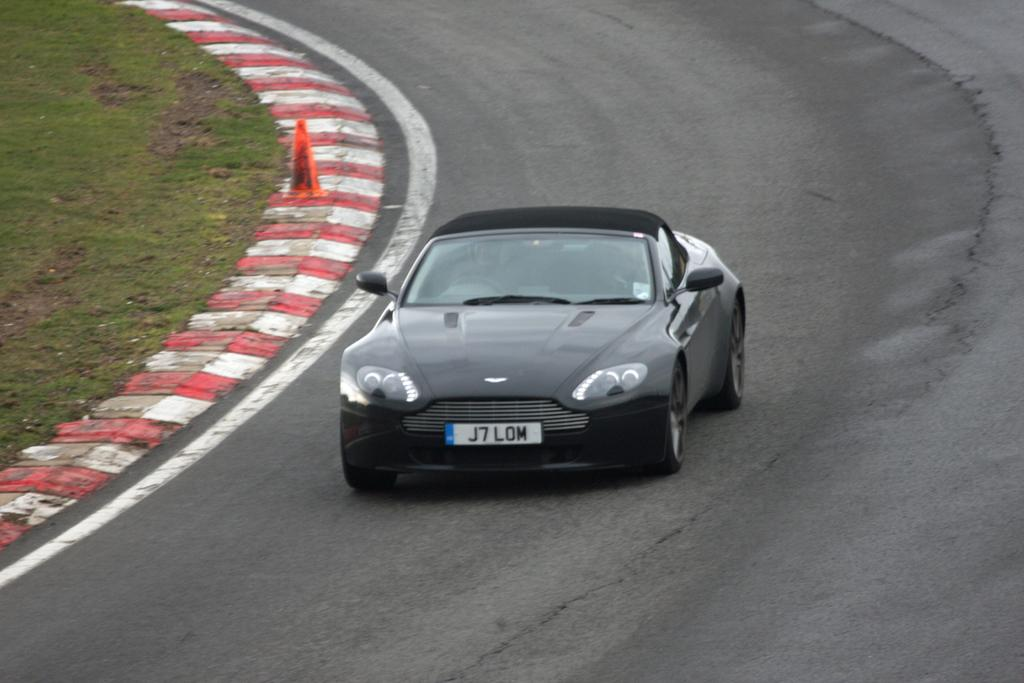What is the main subject of the image? The main subject of the image is a car on the road. Who or what is inside the car? A person is sitting in the car. What can be seen on the divider in the image? There is an inverted cone on the divider. What type of natural environment is visible in the image? There is a grassland visible in the top left corner of the image. What type of toys can be seen hanging from the car's rearview mirror in the image? There are no toys visible in the image, as the focus is on the car, person, inverted cone, and grassland. 